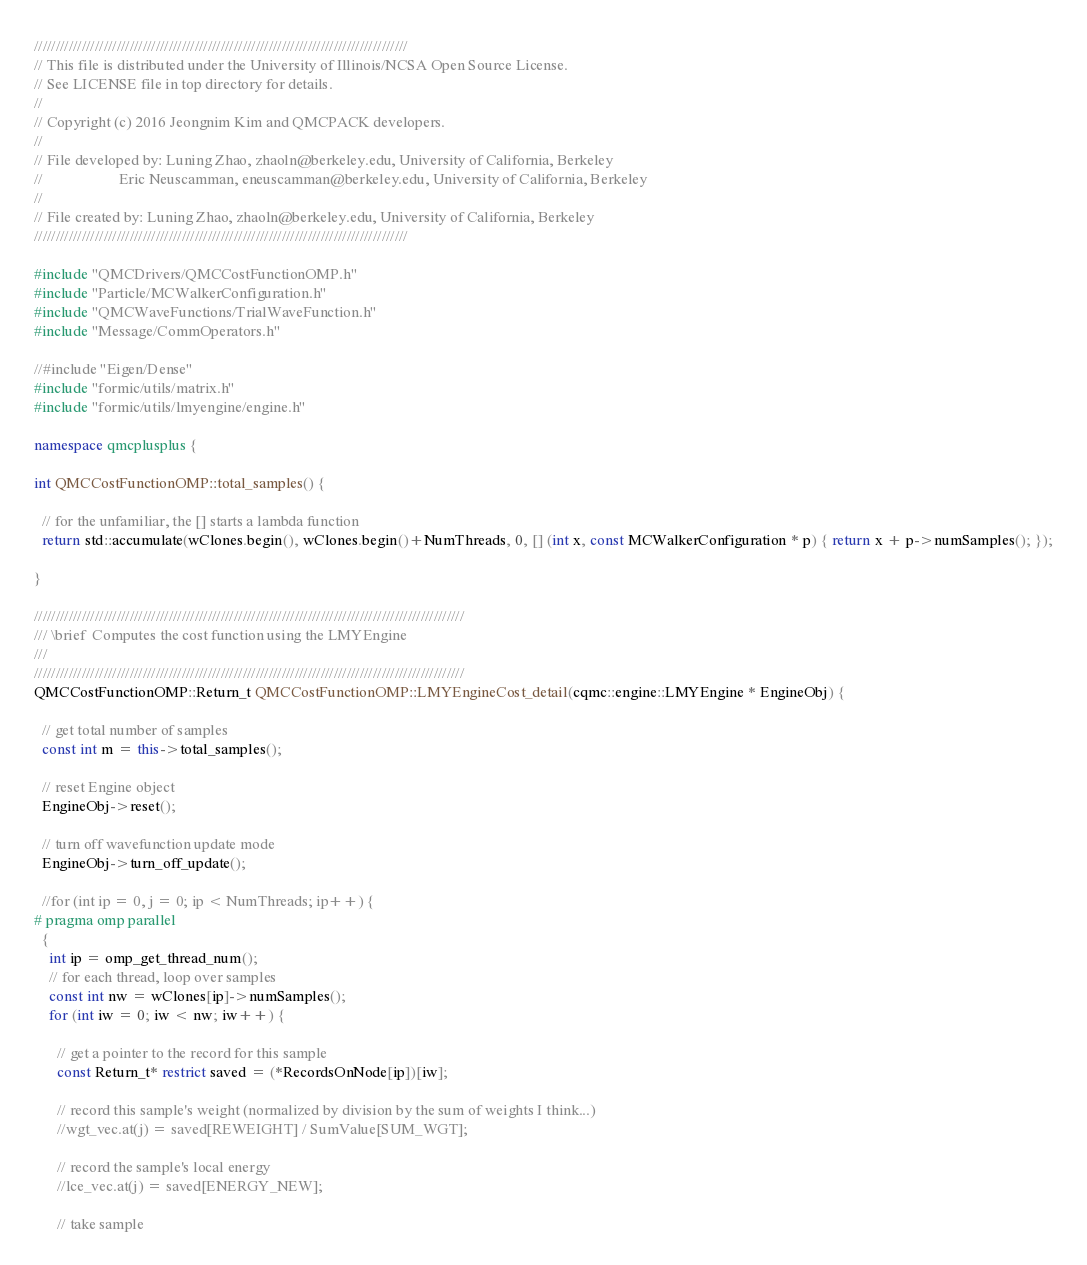<code> <loc_0><loc_0><loc_500><loc_500><_C++_>//////////////////////////////////////////////////////////////////////////////////////
// This file is distributed under the University of Illinois/NCSA Open Source License.
// See LICENSE file in top directory for details.
//
// Copyright (c) 2016 Jeongnim Kim and QMCPACK developers.
//
// File developed by: Luning Zhao, zhaoln@berkeley.edu, University of California, Berkeley
//                    Eric Neuscamman, eneuscamman@berkeley.edu, University of California, Berkeley
//
// File created by: Luning Zhao, zhaoln@berkeley.edu, University of California, Berkeley
//////////////////////////////////////////////////////////////////////////////////////

#include "QMCDrivers/QMCCostFunctionOMP.h"
#include "Particle/MCWalkerConfiguration.h"
#include "QMCWaveFunctions/TrialWaveFunction.h"
#include "Message/CommOperators.h"

//#include "Eigen/Dense"
#include "formic/utils/matrix.h"
#include "formic/utils/lmyengine/engine.h"

namespace qmcplusplus {

int QMCCostFunctionOMP::total_samples() {

  // for the unfamiliar, the [] starts a lambda function
  return std::accumulate(wClones.begin(), wClones.begin()+NumThreads, 0, [] (int x, const MCWalkerConfiguration * p) { return x + p->numSamples(); });

}

///////////////////////////////////////////////////////////////////////////////////////////////////
/// \brief  Computes the cost function using the LMYEngine
///
///////////////////////////////////////////////////////////////////////////////////////////////////
QMCCostFunctionOMP::Return_t QMCCostFunctionOMP::LMYEngineCost_detail(cqmc::engine::LMYEngine * EngineObj) {

  // get total number of samples
  const int m = this->total_samples();

  // reset Engine object 
  EngineObj->reset();

  // turn off wavefunction update mode 
  EngineObj->turn_off_update();

  //for (int ip = 0, j = 0; ip < NumThreads; ip++) {
# pragma omp parallel
  {
    int ip = omp_get_thread_num();     
    // for each thread, loop over samples
    const int nw = wClones[ip]->numSamples();
    for (int iw = 0; iw < nw; iw++) {

      // get a pointer to the record for this sample
      const Return_t* restrict saved = (*RecordsOnNode[ip])[iw];

      // record this sample's weight (normalized by division by the sum of weights I think...)
      //wgt_vec.at(j) = saved[REWEIGHT] / SumValue[SUM_WGT];

      // record the sample's local energy
      //lce_vec.at(j) = saved[ENERGY_NEW];

      // take sample </code> 